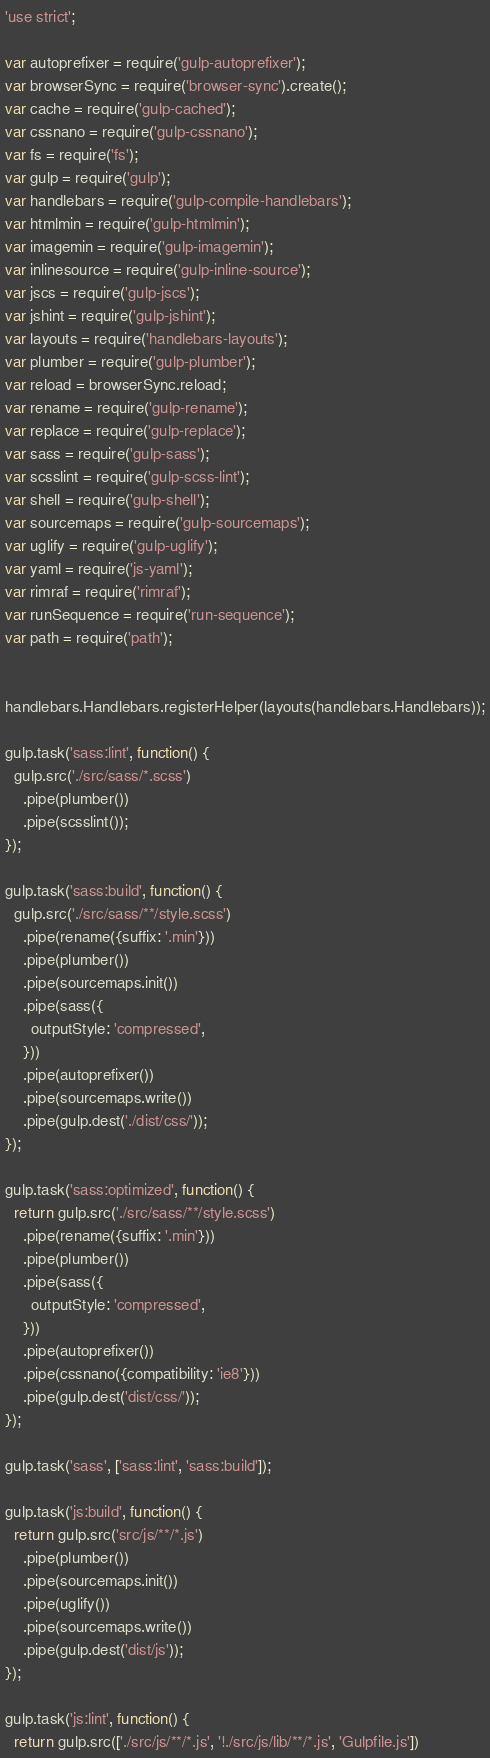<code> <loc_0><loc_0><loc_500><loc_500><_JavaScript_>'use strict';

var autoprefixer = require('gulp-autoprefixer');
var browserSync = require('browser-sync').create();
var cache = require('gulp-cached');
var cssnano = require('gulp-cssnano');
var fs = require('fs');
var gulp = require('gulp');
var handlebars = require('gulp-compile-handlebars');
var htmlmin = require('gulp-htmlmin');
var imagemin = require('gulp-imagemin');
var inlinesource = require('gulp-inline-source');
var jscs = require('gulp-jscs');
var jshint = require('gulp-jshint');
var layouts = require('handlebars-layouts');
var plumber = require('gulp-plumber');
var reload = browserSync.reload;
var rename = require('gulp-rename');
var replace = require('gulp-replace');
var sass = require('gulp-sass');
var scsslint = require('gulp-scss-lint');
var shell = require('gulp-shell');
var sourcemaps = require('gulp-sourcemaps');
var uglify = require('gulp-uglify');
var yaml = require('js-yaml');
var rimraf = require('rimraf');
var runSequence = require('run-sequence');
var path = require('path');


handlebars.Handlebars.registerHelper(layouts(handlebars.Handlebars));

gulp.task('sass:lint', function() {
  gulp.src('./src/sass/*.scss')
    .pipe(plumber())
    .pipe(scsslint());
});

gulp.task('sass:build', function() {
  gulp.src('./src/sass/**/style.scss')
    .pipe(rename({suffix: '.min'}))
    .pipe(plumber())
    .pipe(sourcemaps.init())
    .pipe(sass({
      outputStyle: 'compressed',
    }))
    .pipe(autoprefixer())
    .pipe(sourcemaps.write())
    .pipe(gulp.dest('./dist/css/'));
});

gulp.task('sass:optimized', function() {
  return gulp.src('./src/sass/**/style.scss')
    .pipe(rename({suffix: '.min'}))
    .pipe(plumber())
    .pipe(sass({
      outputStyle: 'compressed',
    }))
    .pipe(autoprefixer())
    .pipe(cssnano({compatibility: 'ie8'}))
    .pipe(gulp.dest('dist/css/'));
});

gulp.task('sass', ['sass:lint', 'sass:build']);

gulp.task('js:build', function() {
  return gulp.src('src/js/**/*.js')
    .pipe(plumber())
    .pipe(sourcemaps.init())
    .pipe(uglify())
    .pipe(sourcemaps.write())
    .pipe(gulp.dest('dist/js'));
});

gulp.task('js:lint', function() {
  return gulp.src(['./src/js/**/*.js', '!./src/js/lib/**/*.js', 'Gulpfile.js'])</code> 